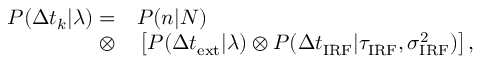Convert formula to latex. <formula><loc_0><loc_0><loc_500><loc_500>\begin{array} { r l } { P ( \Delta t _ { k } | \lambda ) = } & P ( n | N ) } \\ { \otimes } & \left [ P ( \Delta t _ { e x t } | \lambda ) \otimes P ( \Delta t _ { I R F } | \tau _ { I R F } , \sigma _ { I R F } ^ { 2 } ) \right ] , } \end{array}</formula> 